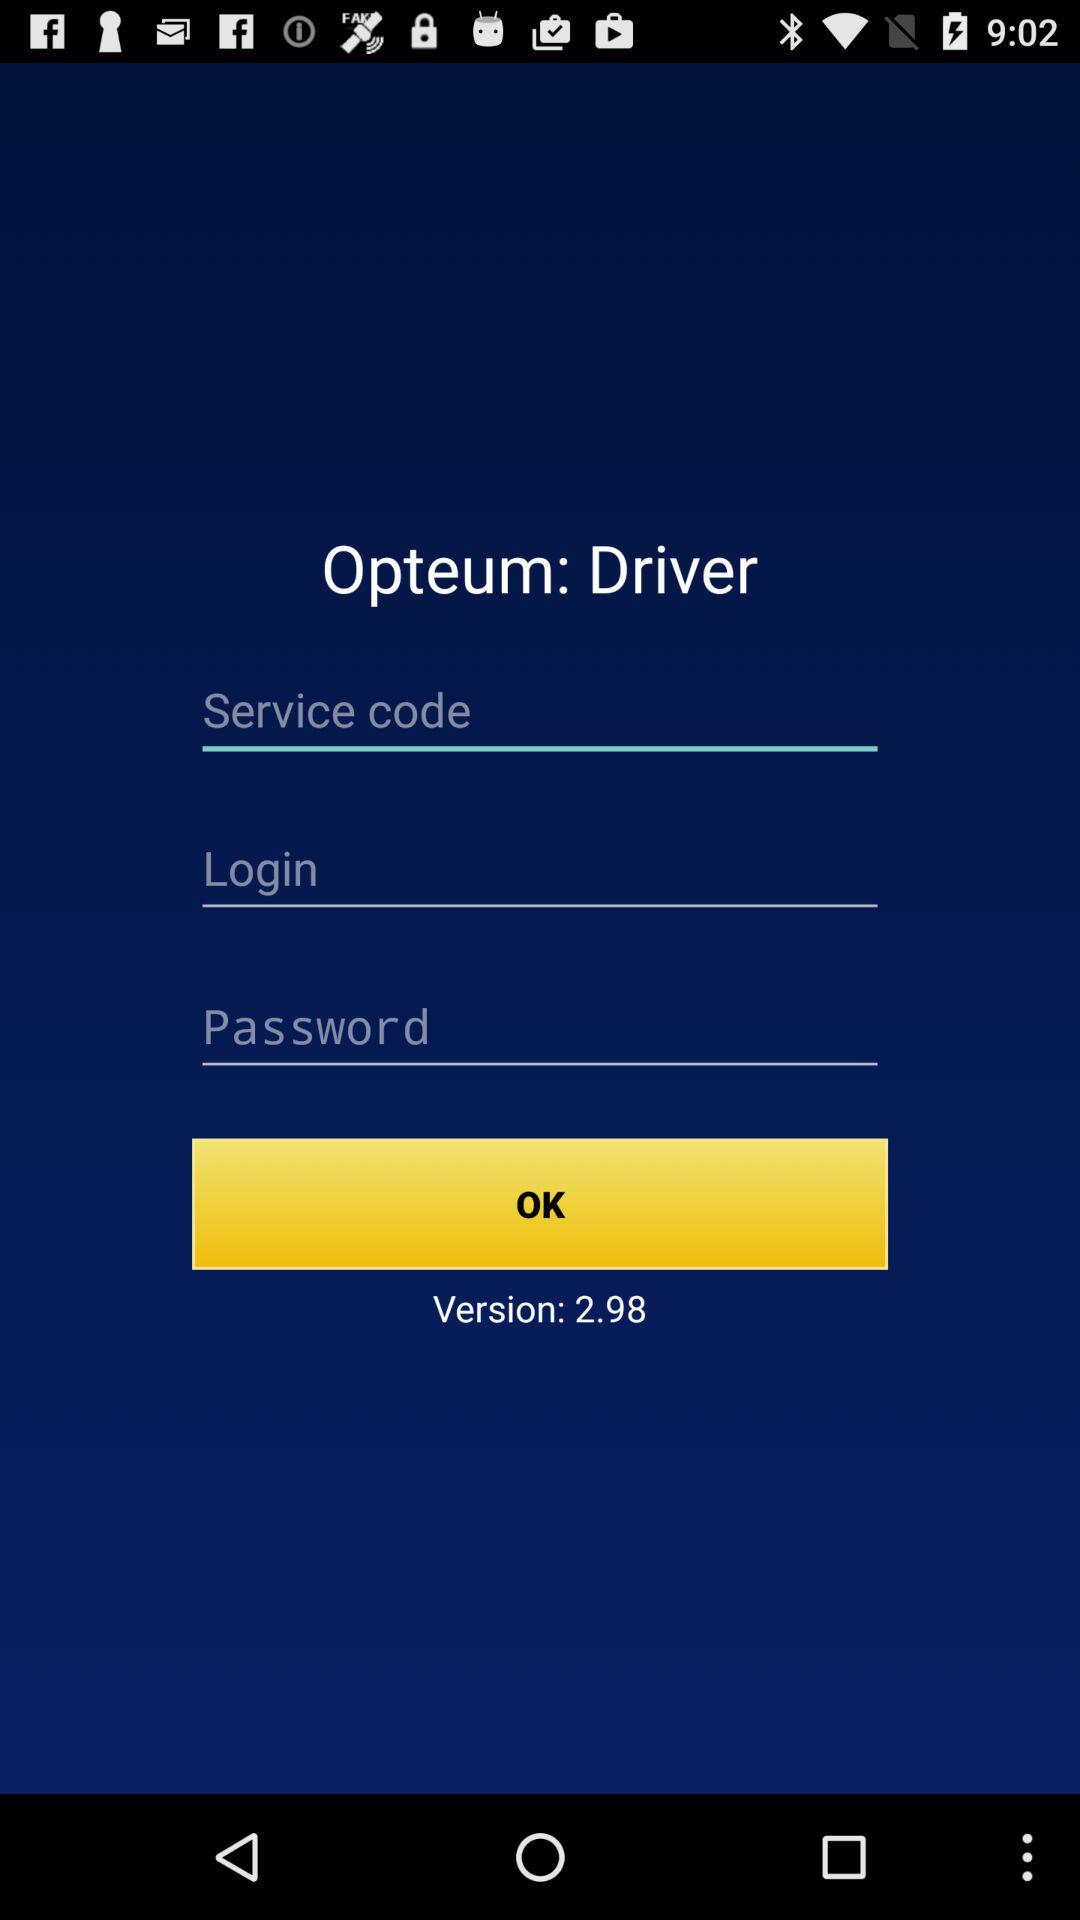What is the version? The version is 2.98. 